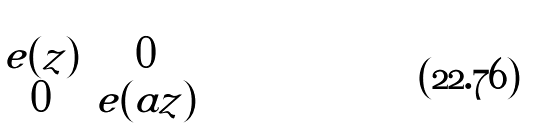Convert formula to latex. <formula><loc_0><loc_0><loc_500><loc_500>\begin{pmatrix} e ( z ) & 0 \\ 0 & e ( a z ) \\ \end{pmatrix}</formula> 